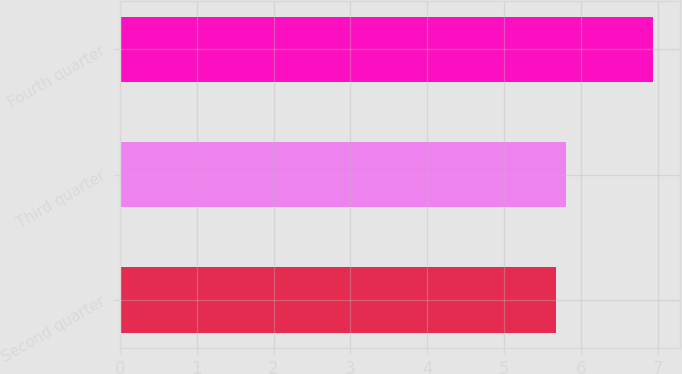<chart> <loc_0><loc_0><loc_500><loc_500><bar_chart><fcel>Second quarter<fcel>Third quarter<fcel>Fourth quarter<nl><fcel>5.67<fcel>5.8<fcel>6.93<nl></chart> 